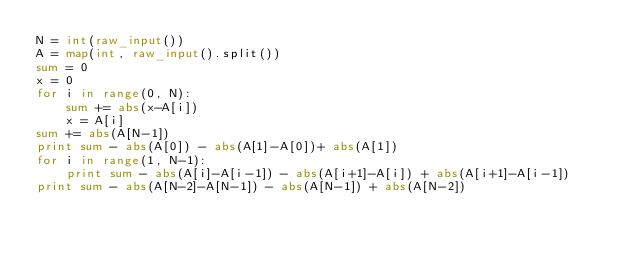Convert code to text. <code><loc_0><loc_0><loc_500><loc_500><_Python_>N = int(raw_input())
A = map(int, raw_input().split())
sum = 0
x = 0
for i in range(0, N):
	sum += abs(x-A[i])
	x = A[i]
sum += abs(A[N-1])
print sum - abs(A[0]) - abs(A[1]-A[0])+ abs(A[1])
for i in range(1, N-1):
	print sum - abs(A[i]-A[i-1]) - abs(A[i+1]-A[i]) + abs(A[i+1]-A[i-1])
print sum - abs(A[N-2]-A[N-1]) - abs(A[N-1]) + abs(A[N-2])</code> 